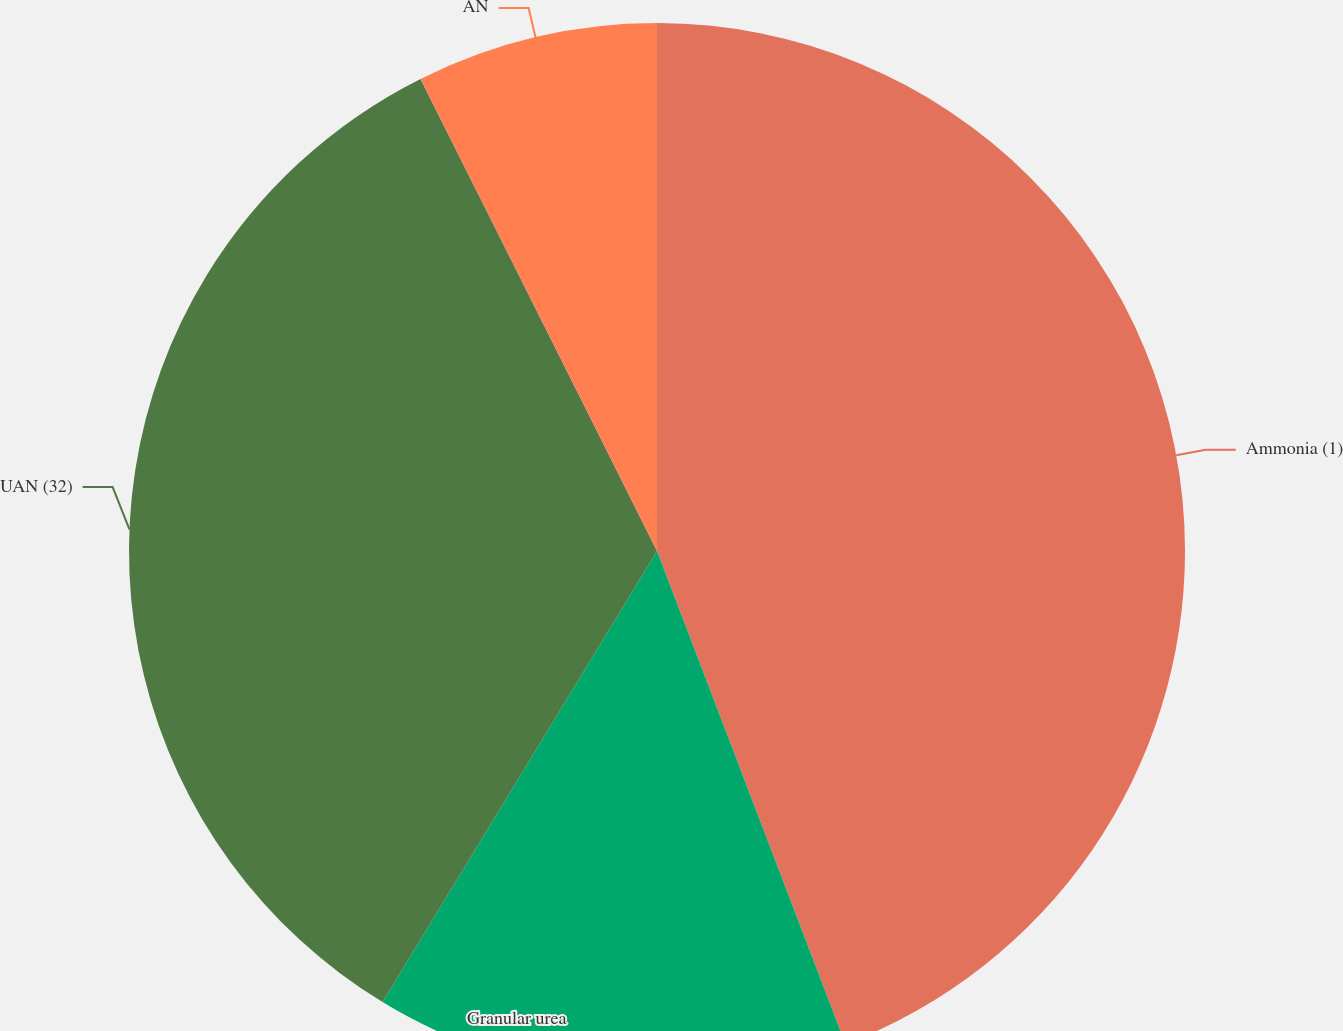<chart> <loc_0><loc_0><loc_500><loc_500><pie_chart><fcel>Ammonia (1)<fcel>Granular urea<fcel>UAN (32)<fcel>AN<nl><fcel>44.19%<fcel>14.51%<fcel>33.91%<fcel>7.39%<nl></chart> 